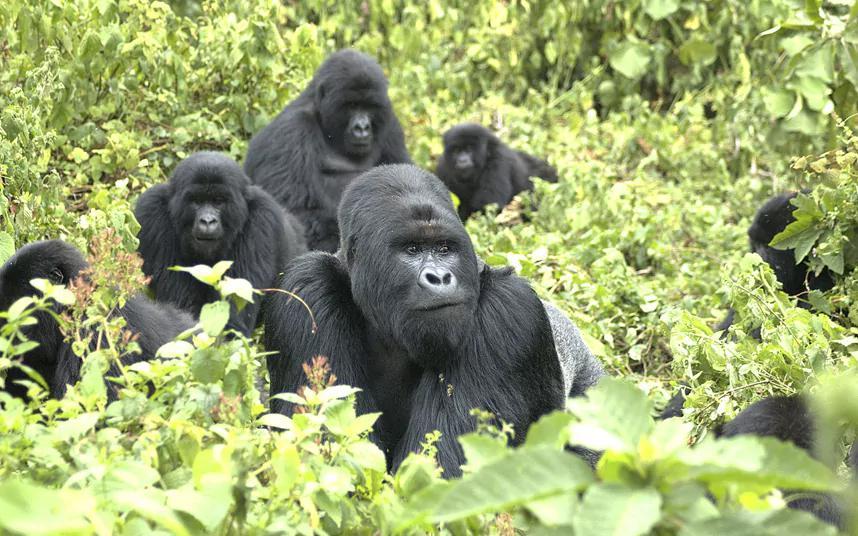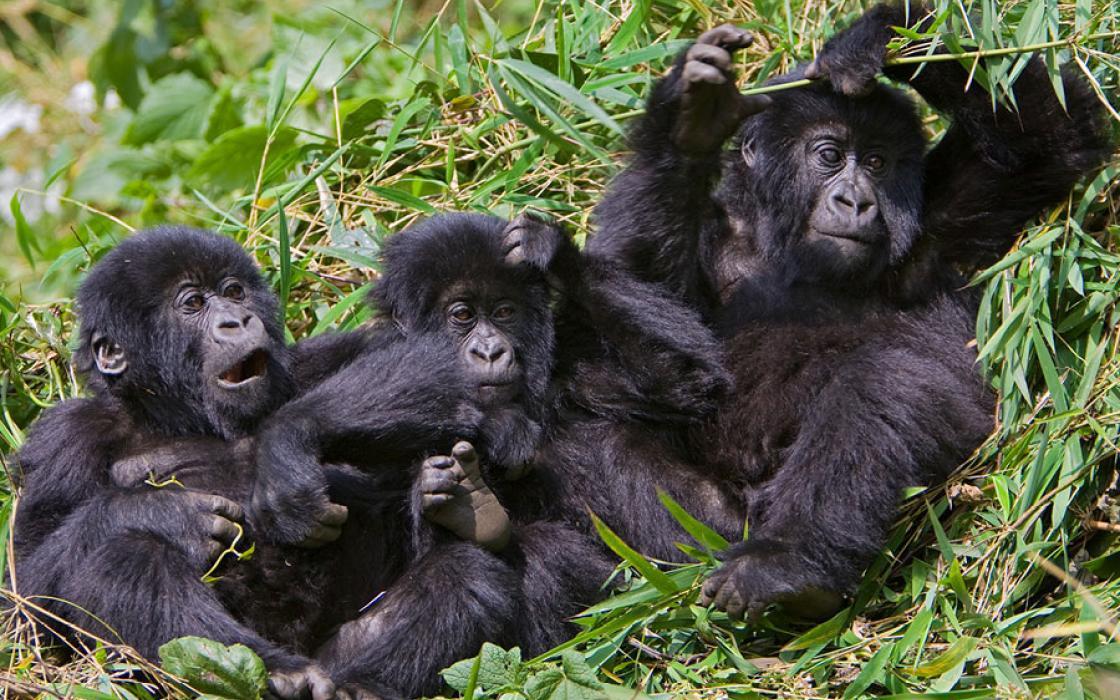The first image is the image on the left, the second image is the image on the right. Examine the images to the left and right. Is the description "One gorilla is scratching its own chin." accurate? Answer yes or no. No. 